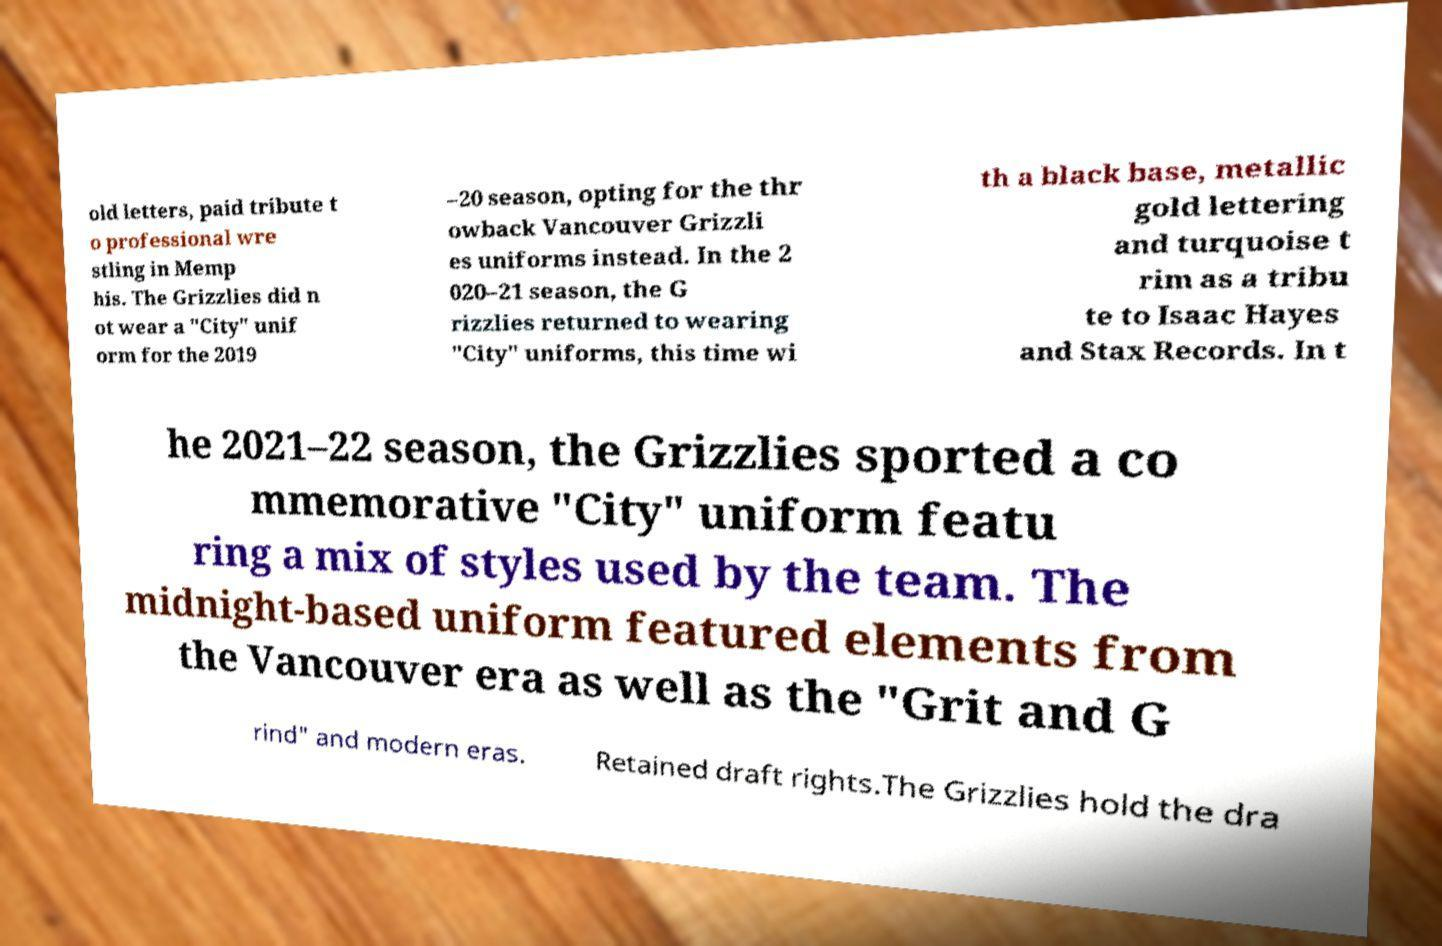Could you extract and type out the text from this image? old letters, paid tribute t o professional wre stling in Memp his. The Grizzlies did n ot wear a "City" unif orm for the 2019 –20 season, opting for the thr owback Vancouver Grizzli es uniforms instead. In the 2 020–21 season, the G rizzlies returned to wearing "City" uniforms, this time wi th a black base, metallic gold lettering and turquoise t rim as a tribu te to Isaac Hayes and Stax Records. In t he 2021–22 season, the Grizzlies sported a co mmemorative "City" uniform featu ring a mix of styles used by the team. The midnight-based uniform featured elements from the Vancouver era as well as the "Grit and G rind" and modern eras. Retained draft rights.The Grizzlies hold the dra 